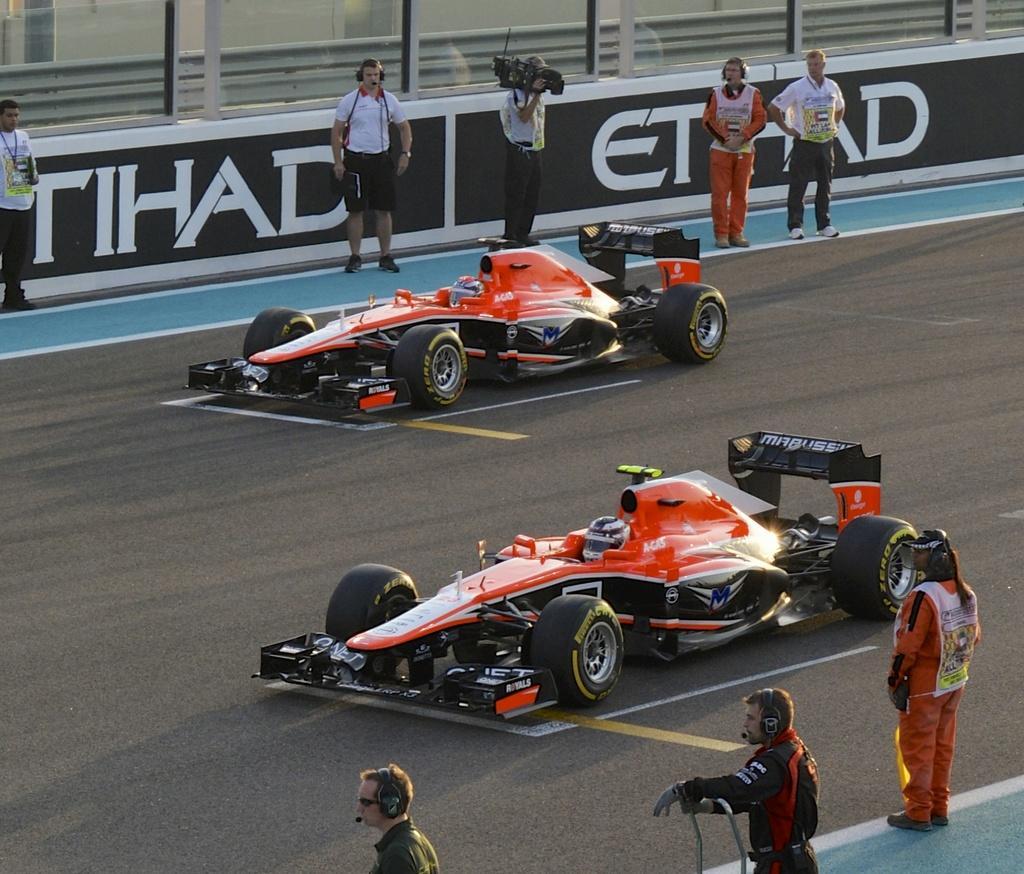In one or two sentences, can you explain what this image depicts? In the image on the road there are vehicles. At the bottom of the image there are three people with headsets. Behind the road there are five people. There is a person holding a video camera in the hands. Behind them there are banners with text on it. Behind those banners there are glass walls. 